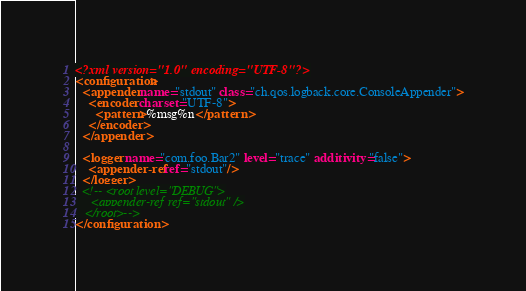Convert code to text. <code><loc_0><loc_0><loc_500><loc_500><_XML_><?xml version="1.0" encoding="UTF-8"?>
<configuration>
  <appender name="stdout" class="ch.qos.logback.core.ConsoleAppender">
    <encoder charset="UTF-8">
      <pattern>%msg%n</pattern>
    </encoder>
  </appender>

  <logger name="com.foo.Bar2" level="trace" additivity="false">
    <appender-ref ref="stdout"/>
  </logger>
  <!-- <root level="DEBUG">
     <appender-ref ref="stdout" />
   </root>-->
</configuration>
</code> 